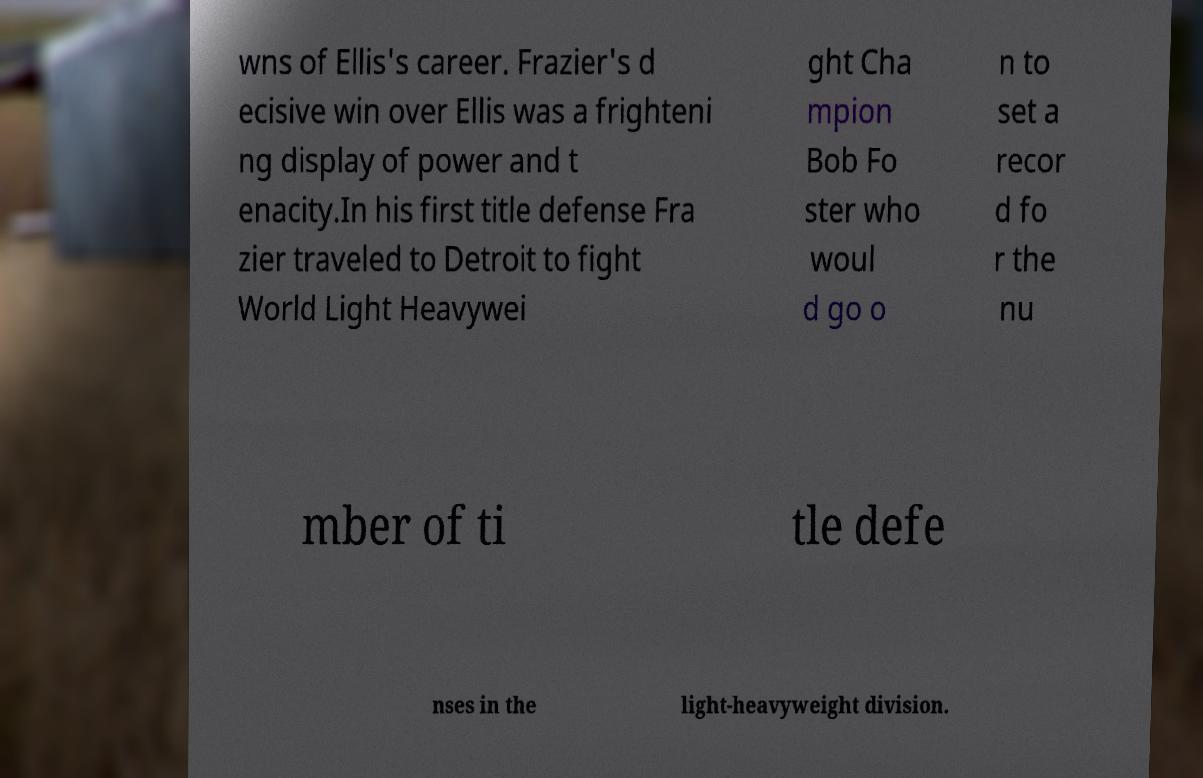For documentation purposes, I need the text within this image transcribed. Could you provide that? wns of Ellis's career. Frazier's d ecisive win over Ellis was a frighteni ng display of power and t enacity.In his first title defense Fra zier traveled to Detroit to fight World Light Heavywei ght Cha mpion Bob Fo ster who woul d go o n to set a recor d fo r the nu mber of ti tle defe nses in the light-heavyweight division. 